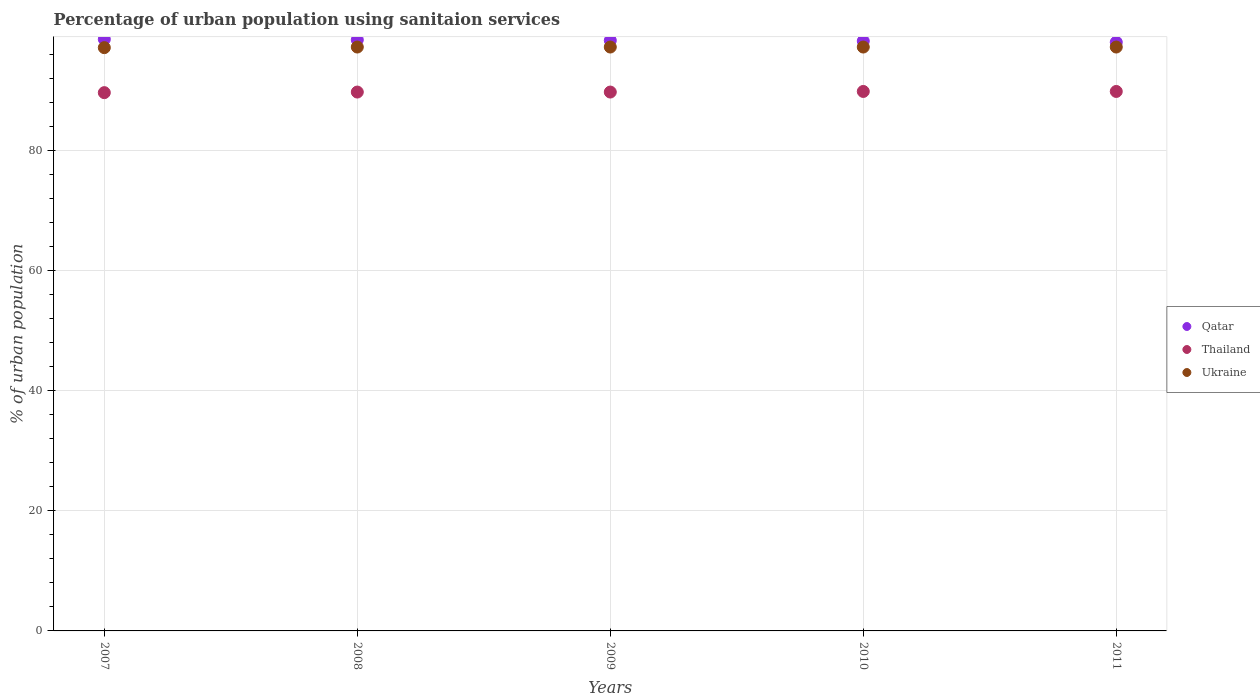How many different coloured dotlines are there?
Give a very brief answer. 3. Is the number of dotlines equal to the number of legend labels?
Offer a very short reply. Yes. What is the percentage of urban population using sanitaion services in Ukraine in 2011?
Your response must be concise. 97.3. Across all years, what is the maximum percentage of urban population using sanitaion services in Thailand?
Provide a succinct answer. 89.9. Across all years, what is the minimum percentage of urban population using sanitaion services in Ukraine?
Your answer should be compact. 97.2. In which year was the percentage of urban population using sanitaion services in Thailand maximum?
Provide a succinct answer. 2010. What is the total percentage of urban population using sanitaion services in Thailand in the graph?
Provide a short and direct response. 449.1. What is the difference between the percentage of urban population using sanitaion services in Qatar in 2008 and that in 2009?
Make the answer very short. 0.1. What is the difference between the percentage of urban population using sanitaion services in Ukraine in 2008 and the percentage of urban population using sanitaion services in Qatar in 2009?
Your response must be concise. -1.1. What is the average percentage of urban population using sanitaion services in Thailand per year?
Keep it short and to the point. 89.82. In the year 2009, what is the difference between the percentage of urban population using sanitaion services in Thailand and percentage of urban population using sanitaion services in Ukraine?
Offer a very short reply. -7.5. What is the ratio of the percentage of urban population using sanitaion services in Thailand in 2007 to that in 2011?
Your answer should be very brief. 1. What is the difference between the highest and the second highest percentage of urban population using sanitaion services in Qatar?
Give a very brief answer. 0.1. What is the difference between the highest and the lowest percentage of urban population using sanitaion services in Ukraine?
Your answer should be compact. 0.1. Is it the case that in every year, the sum of the percentage of urban population using sanitaion services in Ukraine and percentage of urban population using sanitaion services in Qatar  is greater than the percentage of urban population using sanitaion services in Thailand?
Ensure brevity in your answer.  Yes. Is the percentage of urban population using sanitaion services in Ukraine strictly less than the percentage of urban population using sanitaion services in Qatar over the years?
Your answer should be compact. Yes. What is the title of the graph?
Offer a terse response. Percentage of urban population using sanitaion services. Does "Panama" appear as one of the legend labels in the graph?
Your answer should be compact. No. What is the label or title of the Y-axis?
Keep it short and to the point. % of urban population. What is the % of urban population of Qatar in 2007?
Provide a short and direct response. 98.6. What is the % of urban population in Thailand in 2007?
Offer a terse response. 89.7. What is the % of urban population in Ukraine in 2007?
Give a very brief answer. 97.2. What is the % of urban population of Qatar in 2008?
Offer a terse response. 98.5. What is the % of urban population in Thailand in 2008?
Ensure brevity in your answer.  89.8. What is the % of urban population of Ukraine in 2008?
Your response must be concise. 97.3. What is the % of urban population in Qatar in 2009?
Ensure brevity in your answer.  98.4. What is the % of urban population in Thailand in 2009?
Provide a short and direct response. 89.8. What is the % of urban population of Ukraine in 2009?
Your response must be concise. 97.3. What is the % of urban population of Qatar in 2010?
Give a very brief answer. 98.3. What is the % of urban population of Thailand in 2010?
Provide a short and direct response. 89.9. What is the % of urban population in Ukraine in 2010?
Ensure brevity in your answer.  97.3. What is the % of urban population of Qatar in 2011?
Provide a short and direct response. 98.1. What is the % of urban population of Thailand in 2011?
Keep it short and to the point. 89.9. What is the % of urban population of Ukraine in 2011?
Your answer should be compact. 97.3. Across all years, what is the maximum % of urban population of Qatar?
Offer a very short reply. 98.6. Across all years, what is the maximum % of urban population in Thailand?
Offer a very short reply. 89.9. Across all years, what is the maximum % of urban population in Ukraine?
Keep it short and to the point. 97.3. Across all years, what is the minimum % of urban population of Qatar?
Provide a succinct answer. 98.1. Across all years, what is the minimum % of urban population of Thailand?
Your answer should be very brief. 89.7. Across all years, what is the minimum % of urban population in Ukraine?
Provide a short and direct response. 97.2. What is the total % of urban population of Qatar in the graph?
Your answer should be very brief. 491.9. What is the total % of urban population in Thailand in the graph?
Give a very brief answer. 449.1. What is the total % of urban population in Ukraine in the graph?
Offer a terse response. 486.4. What is the difference between the % of urban population of Qatar in 2007 and that in 2008?
Provide a succinct answer. 0.1. What is the difference between the % of urban population of Thailand in 2007 and that in 2008?
Provide a short and direct response. -0.1. What is the difference between the % of urban population of Qatar in 2007 and that in 2009?
Offer a terse response. 0.2. What is the difference between the % of urban population in Thailand in 2007 and that in 2009?
Keep it short and to the point. -0.1. What is the difference between the % of urban population in Thailand in 2007 and that in 2010?
Provide a short and direct response. -0.2. What is the difference between the % of urban population in Ukraine in 2007 and that in 2011?
Provide a succinct answer. -0.1. What is the difference between the % of urban population in Qatar in 2008 and that in 2009?
Offer a very short reply. 0.1. What is the difference between the % of urban population in Thailand in 2008 and that in 2010?
Provide a succinct answer. -0.1. What is the difference between the % of urban population in Qatar in 2008 and that in 2011?
Ensure brevity in your answer.  0.4. What is the difference between the % of urban population of Ukraine in 2008 and that in 2011?
Make the answer very short. 0. What is the difference between the % of urban population of Qatar in 2009 and that in 2010?
Your answer should be compact. 0.1. What is the difference between the % of urban population in Ukraine in 2009 and that in 2010?
Offer a very short reply. 0. What is the difference between the % of urban population in Thailand in 2009 and that in 2011?
Ensure brevity in your answer.  -0.1. What is the difference between the % of urban population in Ukraine in 2009 and that in 2011?
Provide a succinct answer. 0. What is the difference between the % of urban population of Qatar in 2010 and that in 2011?
Offer a very short reply. 0.2. What is the difference between the % of urban population in Qatar in 2007 and the % of urban population in Thailand in 2008?
Provide a succinct answer. 8.8. What is the difference between the % of urban population of Qatar in 2007 and the % of urban population of Thailand in 2009?
Make the answer very short. 8.8. What is the difference between the % of urban population in Qatar in 2007 and the % of urban population in Ukraine in 2009?
Your response must be concise. 1.3. What is the difference between the % of urban population of Thailand in 2007 and the % of urban population of Ukraine in 2009?
Keep it short and to the point. -7.6. What is the difference between the % of urban population of Qatar in 2007 and the % of urban population of Thailand in 2011?
Offer a terse response. 8.7. What is the difference between the % of urban population in Qatar in 2007 and the % of urban population in Ukraine in 2011?
Keep it short and to the point. 1.3. What is the difference between the % of urban population in Qatar in 2008 and the % of urban population in Thailand in 2009?
Your answer should be very brief. 8.7. What is the difference between the % of urban population in Thailand in 2008 and the % of urban population in Ukraine in 2009?
Your answer should be very brief. -7.5. What is the difference between the % of urban population in Qatar in 2008 and the % of urban population in Ukraine in 2010?
Your response must be concise. 1.2. What is the difference between the % of urban population of Thailand in 2008 and the % of urban population of Ukraine in 2010?
Your answer should be compact. -7.5. What is the difference between the % of urban population in Qatar in 2008 and the % of urban population in Thailand in 2011?
Offer a terse response. 8.6. What is the difference between the % of urban population in Qatar in 2008 and the % of urban population in Ukraine in 2011?
Provide a short and direct response. 1.2. What is the difference between the % of urban population of Qatar in 2009 and the % of urban population of Ukraine in 2011?
Keep it short and to the point. 1.1. What is the difference between the % of urban population in Thailand in 2009 and the % of urban population in Ukraine in 2011?
Provide a short and direct response. -7.5. What is the difference between the % of urban population of Qatar in 2010 and the % of urban population of Thailand in 2011?
Provide a succinct answer. 8.4. What is the difference between the % of urban population in Thailand in 2010 and the % of urban population in Ukraine in 2011?
Keep it short and to the point. -7.4. What is the average % of urban population in Qatar per year?
Your answer should be compact. 98.38. What is the average % of urban population in Thailand per year?
Your response must be concise. 89.82. What is the average % of urban population in Ukraine per year?
Give a very brief answer. 97.28. In the year 2007, what is the difference between the % of urban population in Qatar and % of urban population in Thailand?
Your answer should be compact. 8.9. In the year 2007, what is the difference between the % of urban population in Qatar and % of urban population in Ukraine?
Your answer should be compact. 1.4. In the year 2007, what is the difference between the % of urban population of Thailand and % of urban population of Ukraine?
Make the answer very short. -7.5. In the year 2008, what is the difference between the % of urban population of Qatar and % of urban population of Thailand?
Offer a very short reply. 8.7. In the year 2008, what is the difference between the % of urban population in Qatar and % of urban population in Ukraine?
Your answer should be compact. 1.2. In the year 2008, what is the difference between the % of urban population in Thailand and % of urban population in Ukraine?
Give a very brief answer. -7.5. In the year 2010, what is the difference between the % of urban population of Qatar and % of urban population of Thailand?
Provide a succinct answer. 8.4. In the year 2010, what is the difference between the % of urban population in Qatar and % of urban population in Ukraine?
Your answer should be very brief. 1. In the year 2011, what is the difference between the % of urban population in Qatar and % of urban population in Thailand?
Offer a terse response. 8.2. In the year 2011, what is the difference between the % of urban population in Thailand and % of urban population in Ukraine?
Give a very brief answer. -7.4. What is the ratio of the % of urban population of Ukraine in 2007 to that in 2008?
Give a very brief answer. 1. What is the ratio of the % of urban population of Qatar in 2007 to that in 2009?
Your answer should be compact. 1. What is the ratio of the % of urban population in Thailand in 2007 to that in 2009?
Provide a succinct answer. 1. What is the ratio of the % of urban population of Ukraine in 2007 to that in 2009?
Provide a succinct answer. 1. What is the ratio of the % of urban population in Thailand in 2007 to that in 2010?
Your answer should be compact. 1. What is the ratio of the % of urban population of Ukraine in 2007 to that in 2011?
Offer a terse response. 1. What is the ratio of the % of urban population in Thailand in 2008 to that in 2009?
Provide a short and direct response. 1. What is the ratio of the % of urban population in Qatar in 2008 to that in 2011?
Ensure brevity in your answer.  1. What is the ratio of the % of urban population in Ukraine in 2008 to that in 2011?
Your answer should be compact. 1. What is the ratio of the % of urban population of Thailand in 2009 to that in 2010?
Make the answer very short. 1. What is the ratio of the % of urban population in Thailand in 2009 to that in 2011?
Provide a succinct answer. 1. What is the ratio of the % of urban population in Thailand in 2010 to that in 2011?
Your answer should be compact. 1. What is the ratio of the % of urban population in Ukraine in 2010 to that in 2011?
Offer a terse response. 1. What is the difference between the highest and the second highest % of urban population in Ukraine?
Offer a terse response. 0. What is the difference between the highest and the lowest % of urban population in Qatar?
Keep it short and to the point. 0.5. What is the difference between the highest and the lowest % of urban population of Thailand?
Make the answer very short. 0.2. 